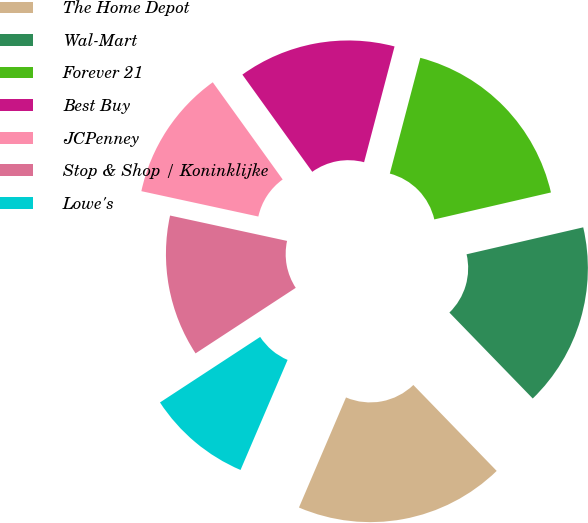Convert chart. <chart><loc_0><loc_0><loc_500><loc_500><pie_chart><fcel>The Home Depot<fcel>Wal-Mart<fcel>Forever 21<fcel>Best Buy<fcel>JCPenney<fcel>Stop & Shop / Koninklijke<fcel>Lowe's<nl><fcel>18.69%<fcel>16.36%<fcel>17.29%<fcel>14.02%<fcel>11.68%<fcel>12.62%<fcel>9.35%<nl></chart> 